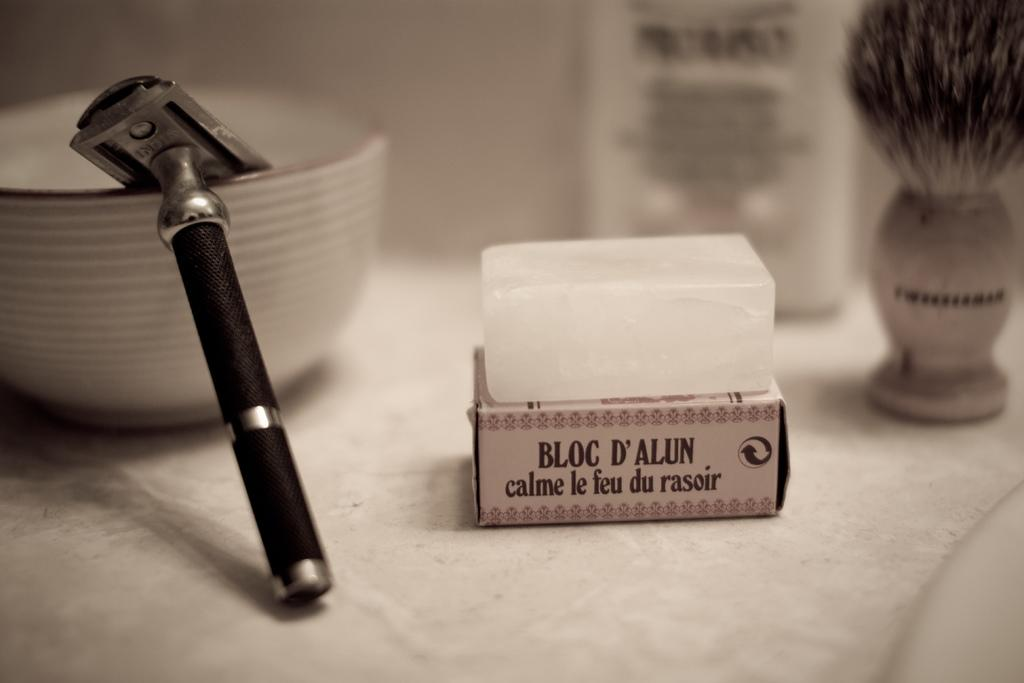<image>
Write a terse but informative summary of the picture. An old fashioned safety razor displayed with an Alum block and shaving brush. 